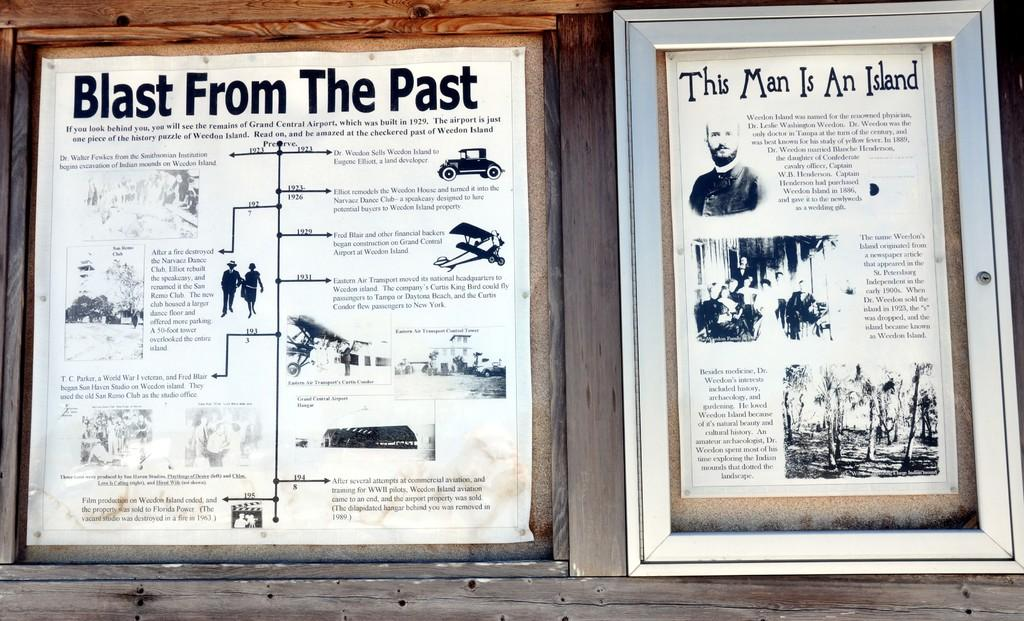<image>
Write a terse but informative summary of the picture. Two posters are on a wall with one being titled Blast From The Past. 